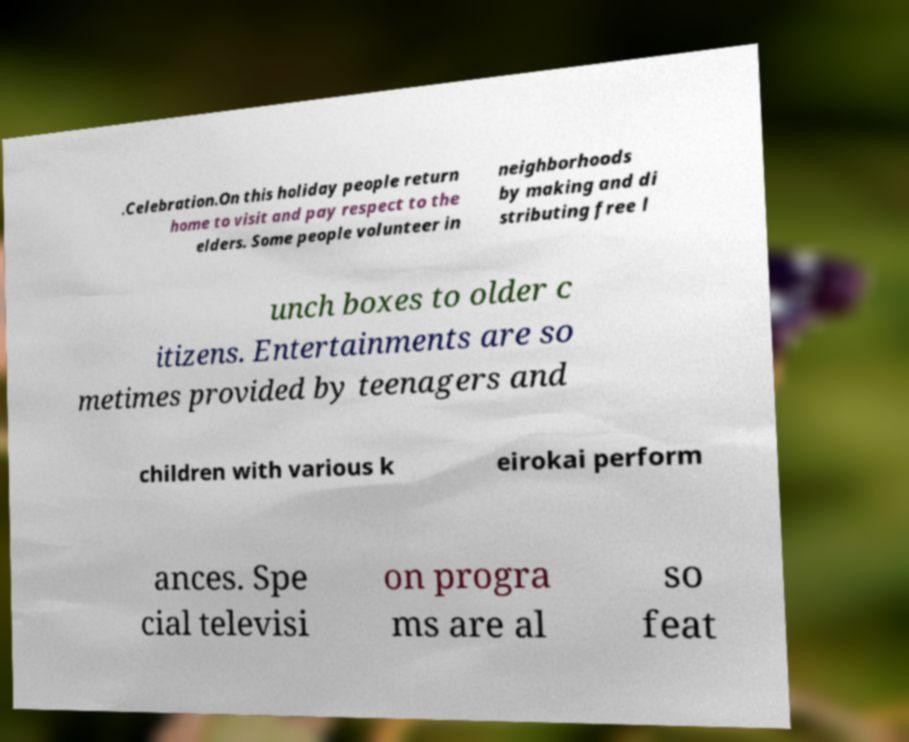Can you read and provide the text displayed in the image?This photo seems to have some interesting text. Can you extract and type it out for me? .Celebration.On this holiday people return home to visit and pay respect to the elders. Some people volunteer in neighborhoods by making and di stributing free l unch boxes to older c itizens. Entertainments are so metimes provided by teenagers and children with various k eirokai perform ances. Spe cial televisi on progra ms are al so feat 